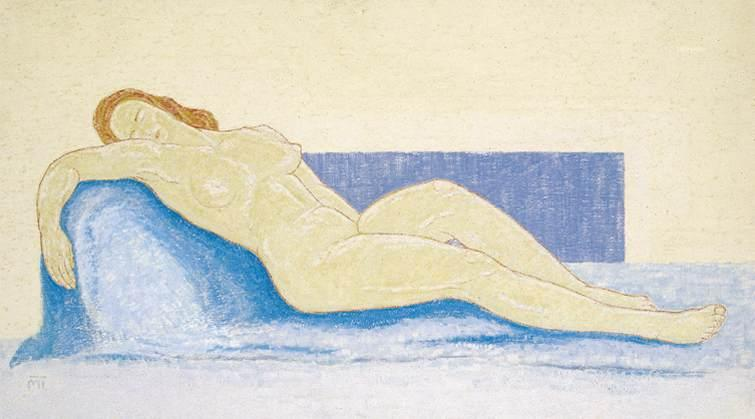What can we infer about the artist’s intention behind depicting the figure in this relaxed pose? The artist’s depiction of the figure in a relaxed, reclining pose likely aims to capture a moment of private repose, emphasizing themes of intimacy and tranquility. This choice can be interpreted as an exploration of the human form in its most natural and unguarded state, inviting viewers to reflect on the beauty and vulnerability of the figure. The positioning might also suggest a narrative of rest or perhaps even dreamlike contemplation, pulling the observer into a personal, introspective moment shared silently with the subject. 